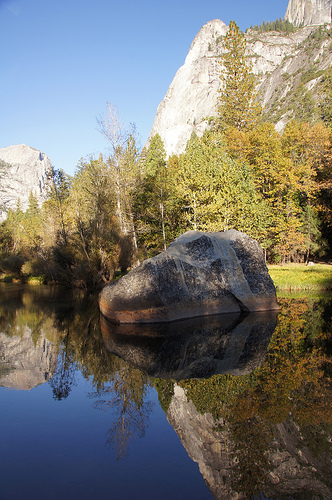<image>
Is there a rock on the water? Yes. Looking at the image, I can see the rock is positioned on top of the water, with the water providing support. 